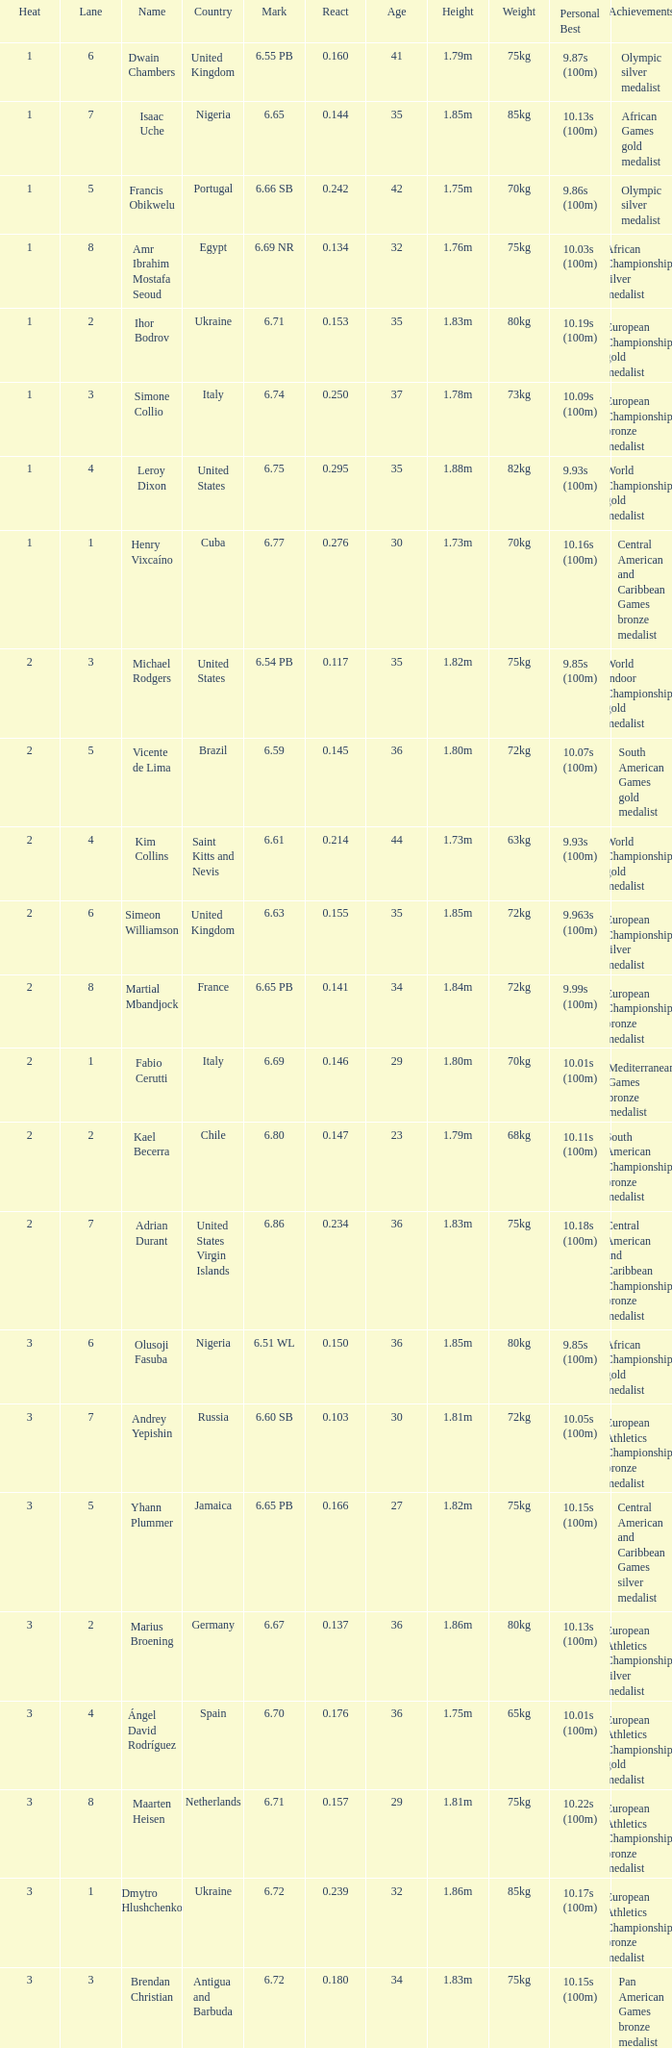What is Mark, when Name is Dmytro Hlushchenko? 6.72. 